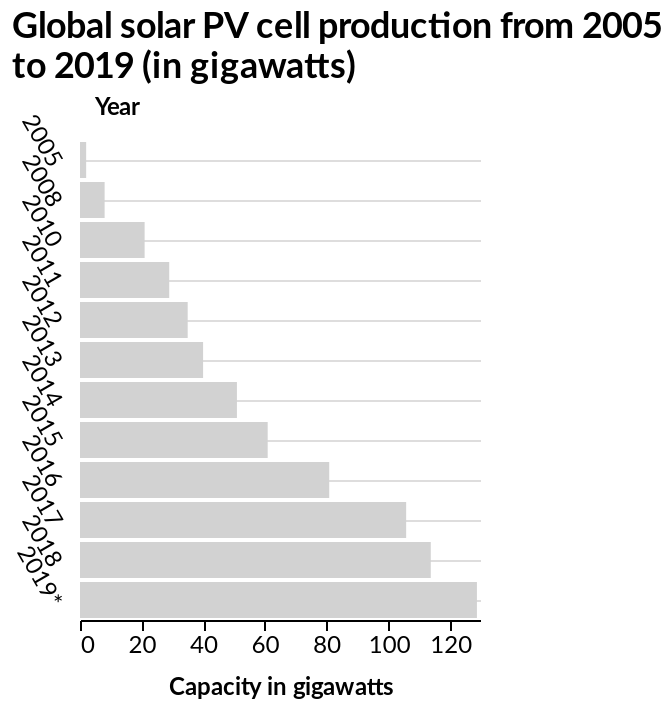<image>
Has the gigawatts capacity remained constant from 2005 to 2019? No, the gigawatts capacity has increased year on year from 2005 to 2019. 